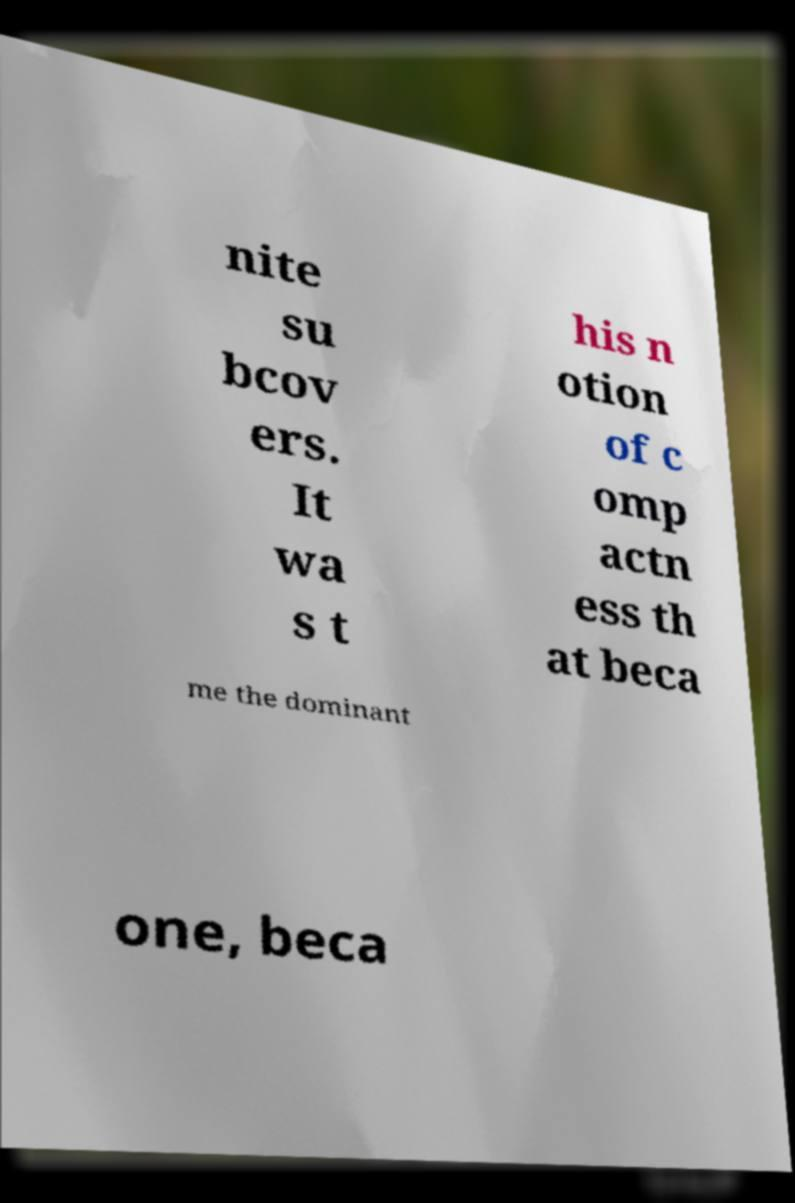Can you read and provide the text displayed in the image?This photo seems to have some interesting text. Can you extract and type it out for me? nite su bcov ers. It wa s t his n otion of c omp actn ess th at beca me the dominant one, beca 